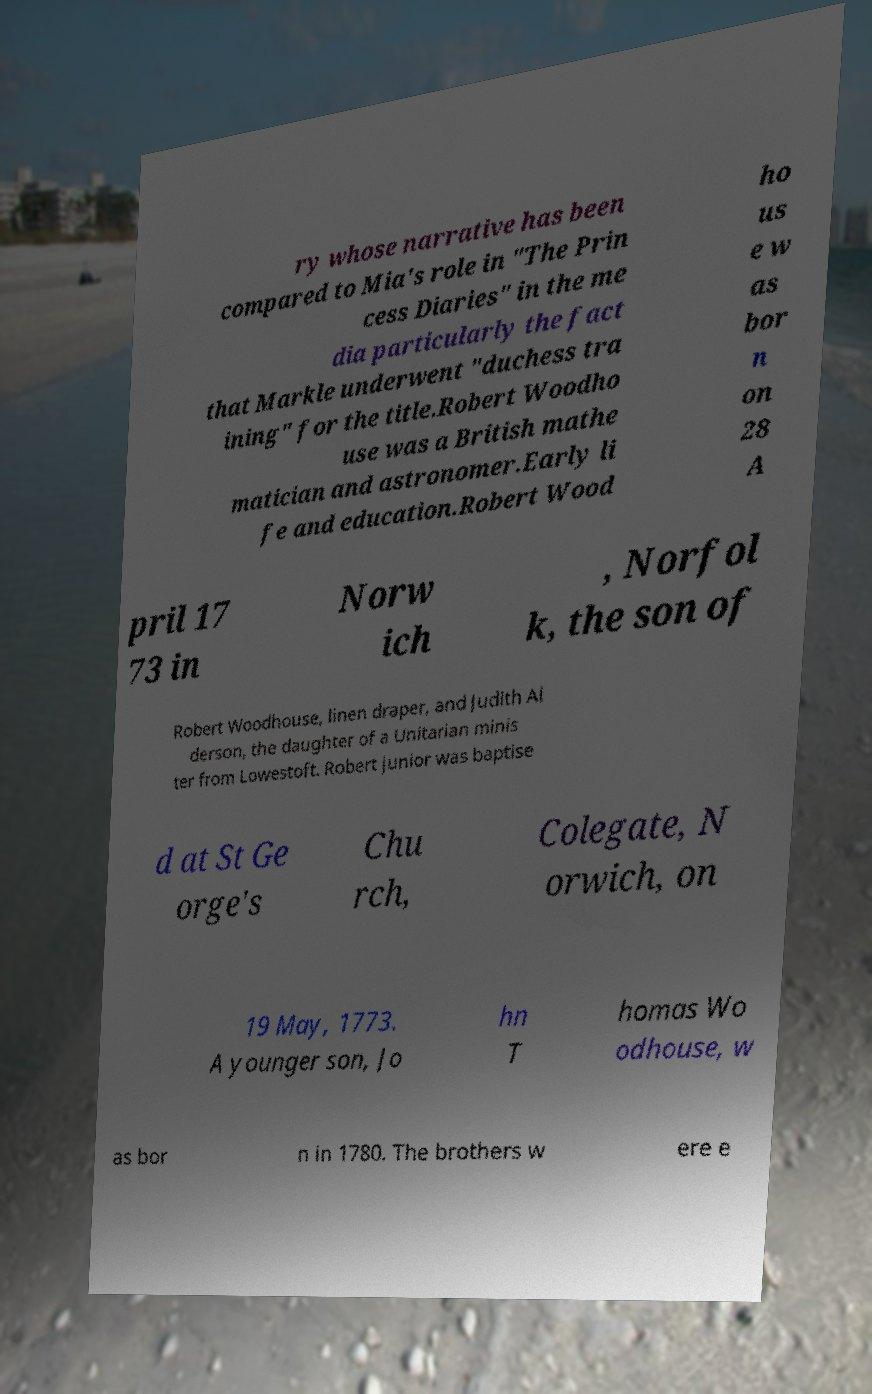I need the written content from this picture converted into text. Can you do that? ry whose narrative has been compared to Mia's role in "The Prin cess Diaries" in the me dia particularly the fact that Markle underwent "duchess tra ining" for the title.Robert Woodho use was a British mathe matician and astronomer.Early li fe and education.Robert Wood ho us e w as bor n on 28 A pril 17 73 in Norw ich , Norfol k, the son of Robert Woodhouse, linen draper, and Judith Al derson, the daughter of a Unitarian minis ter from Lowestoft. Robert junior was baptise d at St Ge orge's Chu rch, Colegate, N orwich, on 19 May, 1773. A younger son, Jo hn T homas Wo odhouse, w as bor n in 1780. The brothers w ere e 